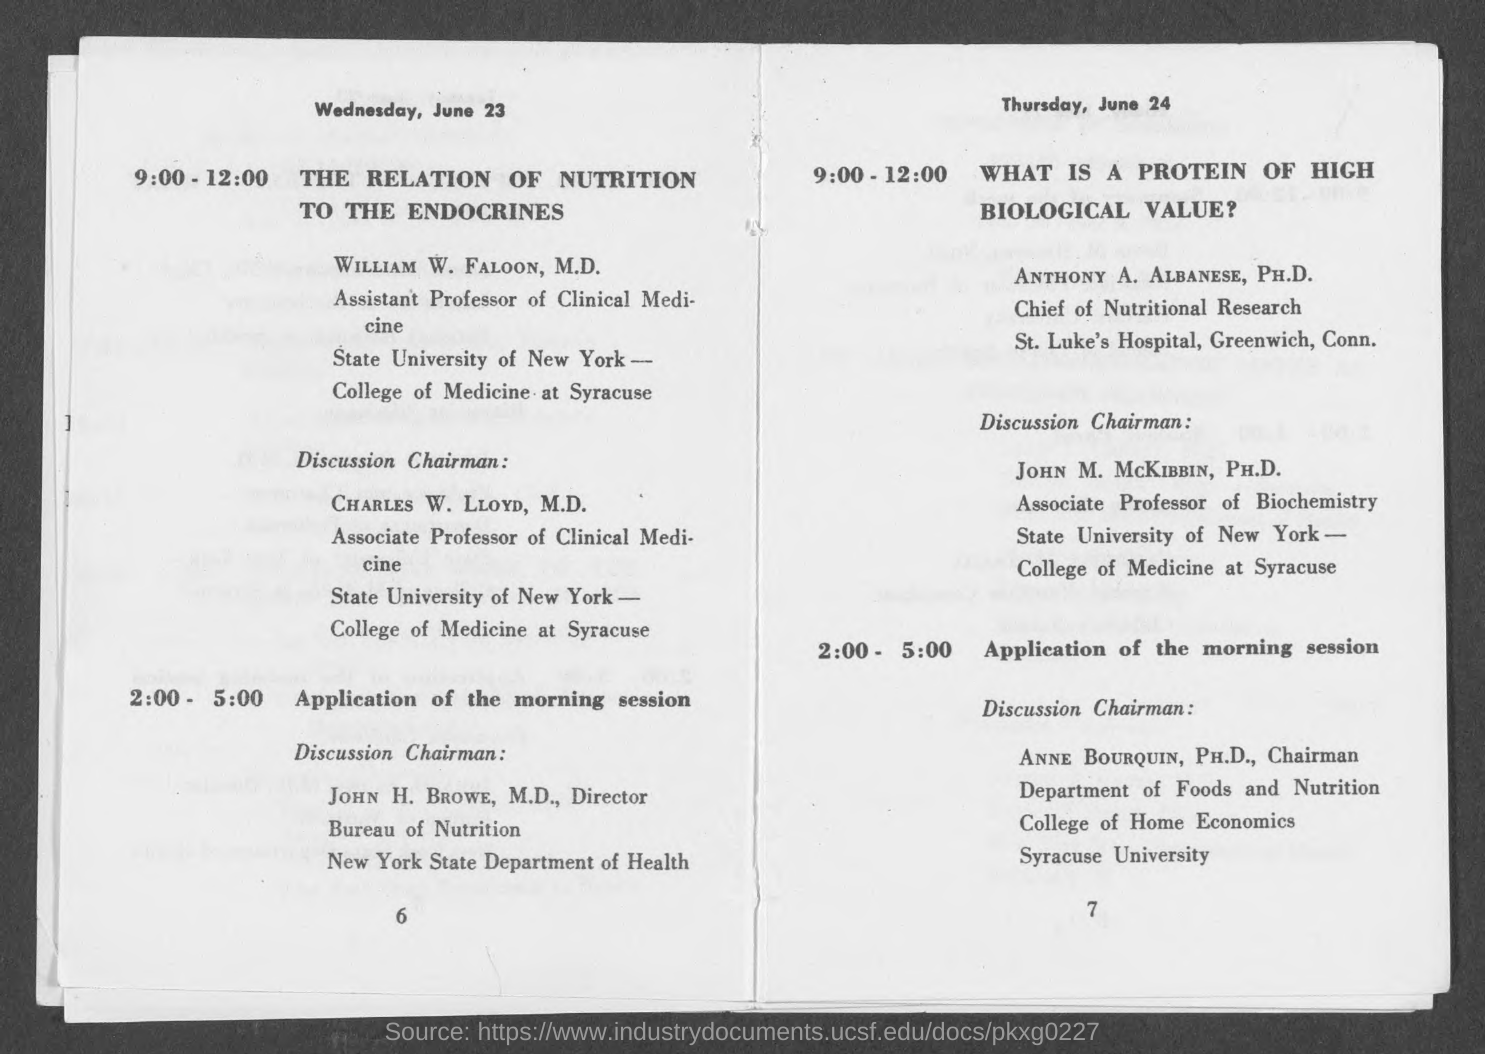List a handful of essential elements in this visual. The identity of the chairman for the morning session discussion on Wednesday, June 23, is John H. Browe, M.D. The morning session on Thursday, June 24, will be chaired by Anne Bourquin, Ph.D., for the discussion. 